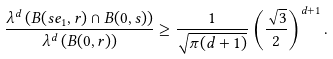Convert formula to latex. <formula><loc_0><loc_0><loc_500><loc_500>\frac { \lambda ^ { d } \left ( B ( s e _ { 1 } , r ) \cap B ( 0 , s ) \right ) } { \lambda ^ { d } \left ( B ( 0 , r ) \right ) } \geq \frac { 1 } { \sqrt { \pi ( d + 1 ) } } \left ( \frac { \sqrt { 3 } } { 2 } \right ) ^ { d + 1 } .</formula> 